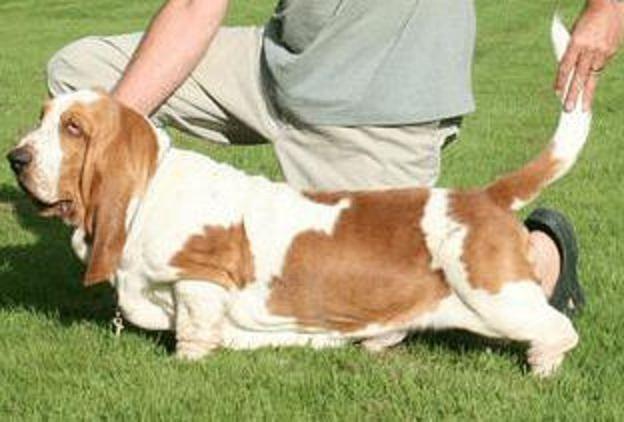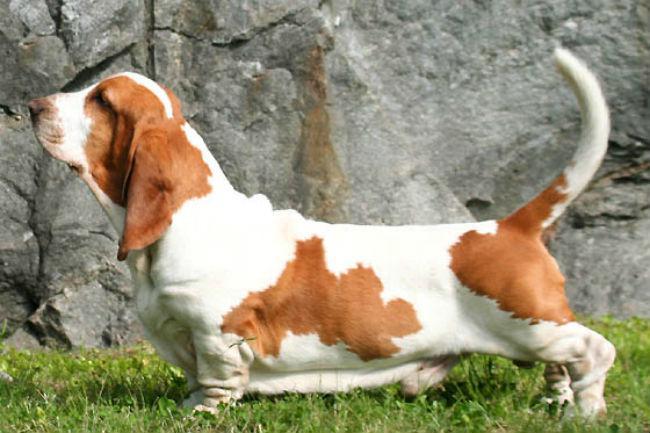The first image is the image on the left, the second image is the image on the right. For the images shown, is this caption "There are fewer than four hounds here." true? Answer yes or no. Yes. The first image is the image on the left, the second image is the image on the right. Considering the images on both sides, is "At least one dog is resting its head." valid? Answer yes or no. No. 